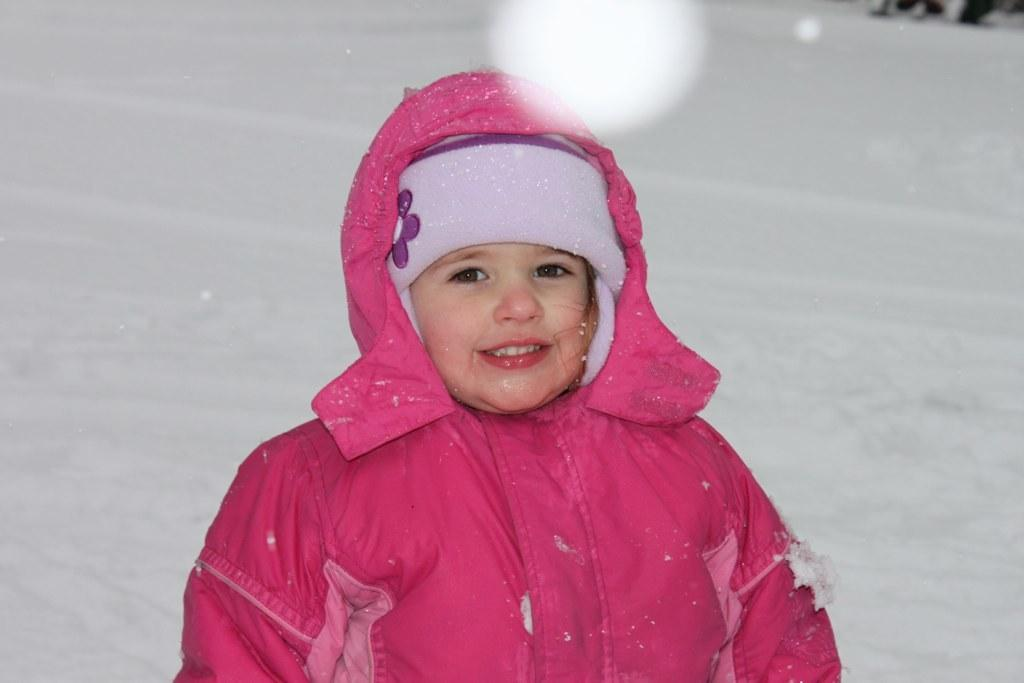What is the main subject of the image? There is a girl standing in the image. What is the girl wearing? The girl is wearing a pink coat. What is the ground covered with in the image? There is snow on the floor in the image. What can be seen in the background of the image? There is snow in the backdrop of the image. How many clocks are visible in the image? There are no clocks visible in the image. What type of underwear is the girl wearing in the image? The girl's clothing is not described in enough detail to determine the type of underwear she is wearing, and there is no reason to assume she is wearing any. 